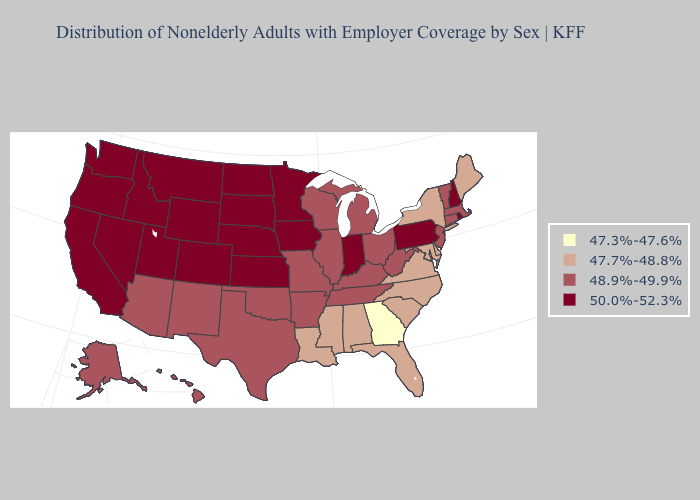What is the lowest value in the USA?
Concise answer only. 47.3%-47.6%. Name the states that have a value in the range 48.9%-49.9%?
Concise answer only. Alaska, Arizona, Arkansas, Connecticut, Hawaii, Illinois, Kentucky, Massachusetts, Michigan, Missouri, New Jersey, New Mexico, Ohio, Oklahoma, Tennessee, Texas, Vermont, West Virginia, Wisconsin. Name the states that have a value in the range 48.9%-49.9%?
Give a very brief answer. Alaska, Arizona, Arkansas, Connecticut, Hawaii, Illinois, Kentucky, Massachusetts, Michigan, Missouri, New Jersey, New Mexico, Ohio, Oklahoma, Tennessee, Texas, Vermont, West Virginia, Wisconsin. Does Pennsylvania have a lower value than Oregon?
Answer briefly. No. Which states hav the highest value in the Northeast?
Short answer required. New Hampshire, Pennsylvania, Rhode Island. Name the states that have a value in the range 48.9%-49.9%?
Keep it brief. Alaska, Arizona, Arkansas, Connecticut, Hawaii, Illinois, Kentucky, Massachusetts, Michigan, Missouri, New Jersey, New Mexico, Ohio, Oklahoma, Tennessee, Texas, Vermont, West Virginia, Wisconsin. Which states hav the highest value in the Northeast?
Concise answer only. New Hampshire, Pennsylvania, Rhode Island. Name the states that have a value in the range 48.9%-49.9%?
Quick response, please. Alaska, Arizona, Arkansas, Connecticut, Hawaii, Illinois, Kentucky, Massachusetts, Michigan, Missouri, New Jersey, New Mexico, Ohio, Oklahoma, Tennessee, Texas, Vermont, West Virginia, Wisconsin. Which states have the lowest value in the USA?
Answer briefly. Georgia. Among the states that border Iowa , which have the highest value?
Answer briefly. Minnesota, Nebraska, South Dakota. Does Minnesota have the highest value in the USA?
Answer briefly. Yes. Does New Jersey have the same value as Idaho?
Be succinct. No. Does the first symbol in the legend represent the smallest category?
Answer briefly. Yes. Name the states that have a value in the range 48.9%-49.9%?
Be succinct. Alaska, Arizona, Arkansas, Connecticut, Hawaii, Illinois, Kentucky, Massachusetts, Michigan, Missouri, New Jersey, New Mexico, Ohio, Oklahoma, Tennessee, Texas, Vermont, West Virginia, Wisconsin. 